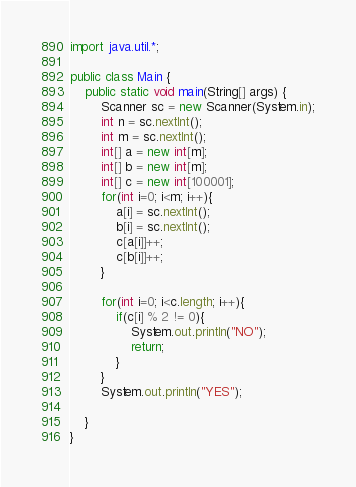<code> <loc_0><loc_0><loc_500><loc_500><_Java_>import java.util.*;

public class Main {
    public static void main(String[] args) {
        Scanner sc = new Scanner(System.in);
        int n = sc.nextInt();
        int m = sc.nextInt();
        int[] a = new int[m];
        int[] b = new int[m];
        int[] c = new int[100001];
        for(int i=0; i<m; i++){
            a[i] = sc.nextInt();
            b[i] = sc.nextInt();
            c[a[i]]++;
            c[b[i]]++;
        }

        for(int i=0; i<c.length; i++){
            if(c[i] % 2 != 0){
                System.out.println("NO");
                return;
            }
        }
        System.out.println("YES");

    }
}</code> 